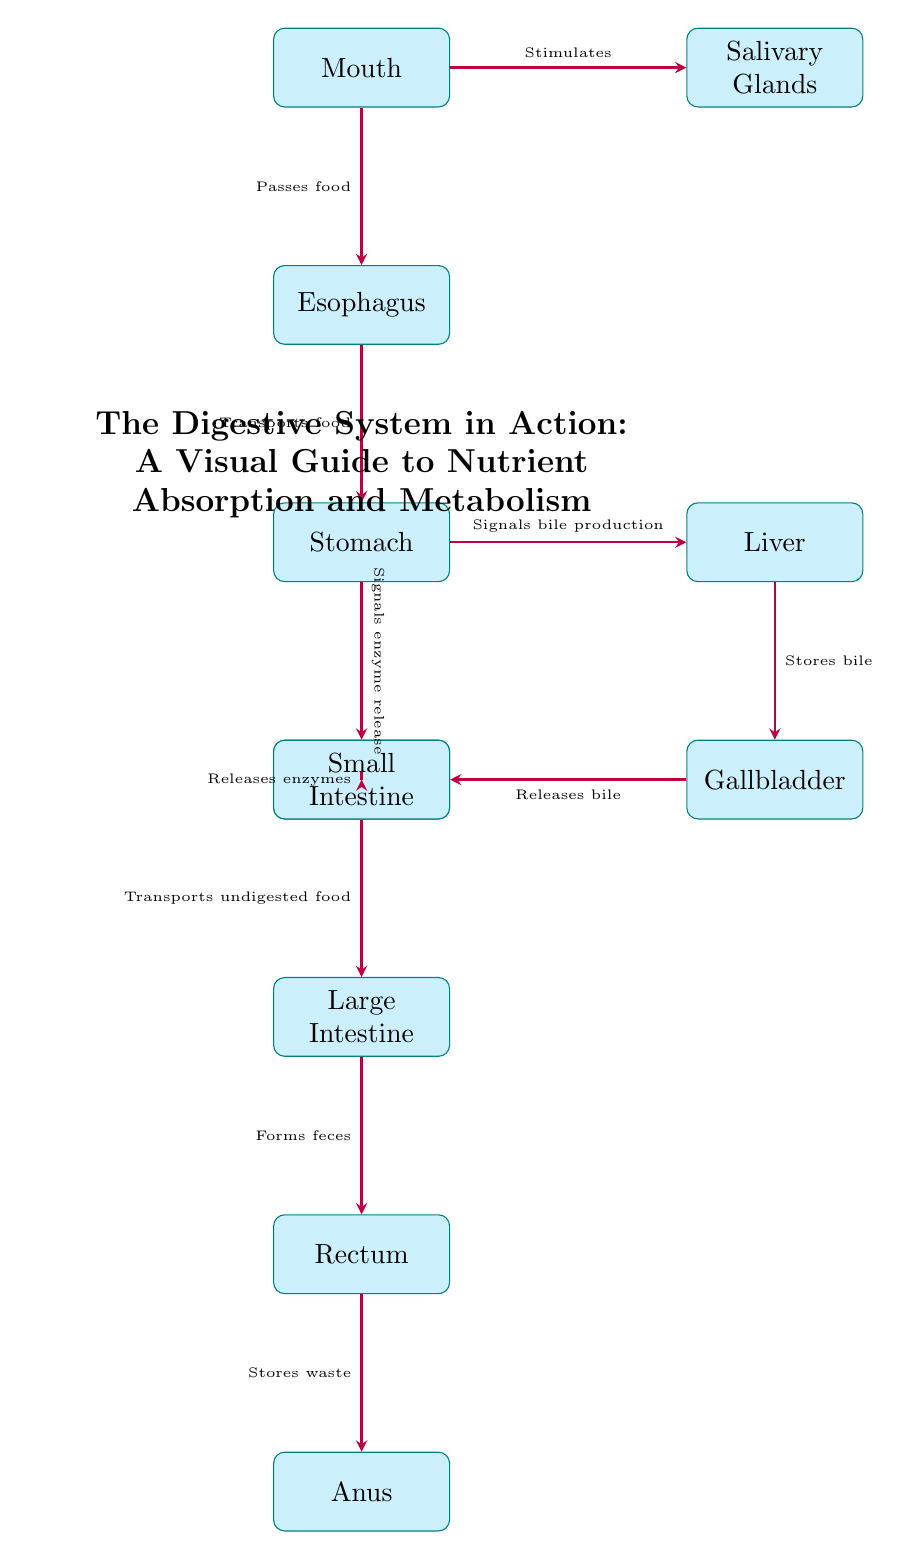What organ follows the mouth? According to the diagram, the organ positioned directly below the mouth is the esophagus.
Answer: Esophagus What does the liver store? The diagram indicates that the liver's function includes storing bile, which is shown with an arrow pointing towards the gallbladder.
Answer: Bile How many main organs are involved in the digestive process as shown in the diagram? The diagram lists 10 organs involved in the digestive system, counting from the mouth to the anus.
Answer: 10 What does the pancreas do in relation to the small intestine? The diagram illustrates that the pancreas releases enzymes into the small intestine as indicated by the arrow.
Answer: Releases enzymes What is formed in the large intestine? The diagram shows a direct connection to the rectum, which indicates that the large intestine is responsible for forming feces.
Answer: Feces How do salivary glands interact with the mouth? The diagram depicts that salivary glands are stimulated by the mouth, indicating their initial role in digestion.
Answer: Stimulates What is the order of the organs from ingestion to excretion, starting from the mouth? Following the sequence in the diagram, the order is mouth, esophagus, stomach, small intestine, large intestine, rectum, anus.
Answer: Mouth, esophagus, stomach, small intestine, large intestine, rectum, anus What does the arrow from the stomach to the liver indicate? The arrow signifies that the stomach signals bile production in the liver as part of the digestive process.
Answer: Signals bile production What organ directly receives bile from the gallbladder? The diagram shows that the small intestine is the organ that receives bile released from the gallbladder.
Answer: Small intestine 